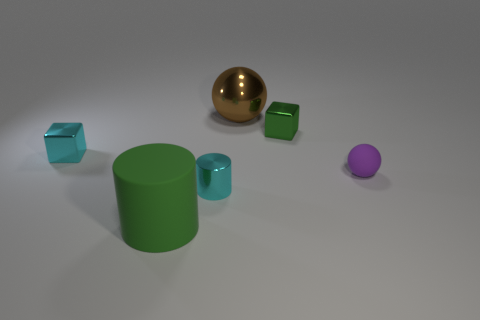Add 2 tiny cyan blocks. How many objects exist? 8 Subtract 1 cubes. How many cubes are left? 1 Subtract all brown spheres. How many spheres are left? 1 Add 2 cyan metallic cylinders. How many cyan metallic cylinders are left? 3 Add 2 green objects. How many green objects exist? 4 Subtract 1 purple balls. How many objects are left? 5 Subtract all cyan spheres. Subtract all gray blocks. How many spheres are left? 2 Subtract all gray blocks. How many green balls are left? 0 Subtract all small gray rubber cubes. Subtract all big spheres. How many objects are left? 5 